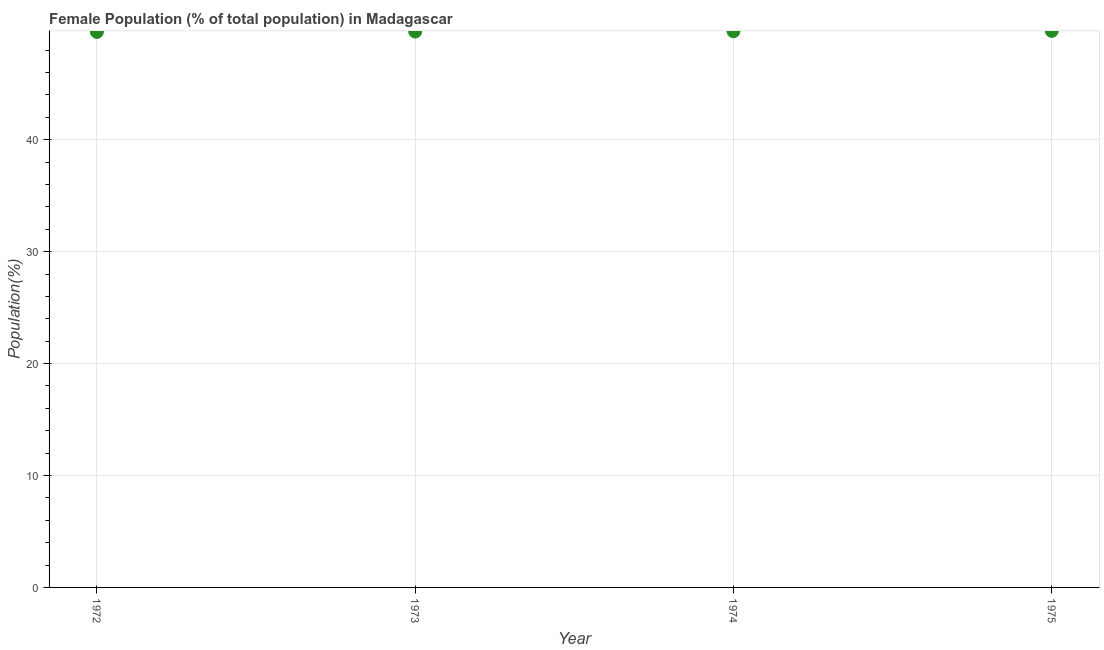What is the female population in 1975?
Keep it short and to the point. 49.72. Across all years, what is the maximum female population?
Offer a very short reply. 49.72. Across all years, what is the minimum female population?
Offer a terse response. 49.63. In which year was the female population maximum?
Keep it short and to the point. 1975. In which year was the female population minimum?
Offer a very short reply. 1972. What is the sum of the female population?
Offer a very short reply. 198.7. What is the difference between the female population in 1973 and 1974?
Offer a very short reply. -0.03. What is the average female population per year?
Your answer should be very brief. 49.67. What is the median female population?
Keep it short and to the point. 49.67. In how many years, is the female population greater than 8 %?
Make the answer very short. 4. What is the ratio of the female population in 1973 to that in 1975?
Give a very brief answer. 1. What is the difference between the highest and the second highest female population?
Keep it short and to the point. 0.03. Is the sum of the female population in 1972 and 1975 greater than the maximum female population across all years?
Make the answer very short. Yes. What is the difference between the highest and the lowest female population?
Ensure brevity in your answer.  0.1. In how many years, is the female population greater than the average female population taken over all years?
Keep it short and to the point. 2. Does the female population monotonically increase over the years?
Provide a short and direct response. Yes. How many dotlines are there?
Offer a terse response. 1. What is the difference between two consecutive major ticks on the Y-axis?
Offer a very short reply. 10. Does the graph contain any zero values?
Offer a terse response. No. Does the graph contain grids?
Offer a very short reply. Yes. What is the title of the graph?
Your response must be concise. Female Population (% of total population) in Madagascar. What is the label or title of the Y-axis?
Offer a very short reply. Population(%). What is the Population(%) in 1972?
Keep it short and to the point. 49.63. What is the Population(%) in 1973?
Ensure brevity in your answer.  49.66. What is the Population(%) in 1974?
Keep it short and to the point. 49.69. What is the Population(%) in 1975?
Your answer should be compact. 49.72. What is the difference between the Population(%) in 1972 and 1973?
Your response must be concise. -0.03. What is the difference between the Population(%) in 1972 and 1974?
Your response must be concise. -0.06. What is the difference between the Population(%) in 1972 and 1975?
Ensure brevity in your answer.  -0.1. What is the difference between the Population(%) in 1973 and 1974?
Your answer should be compact. -0.03. What is the difference between the Population(%) in 1973 and 1975?
Give a very brief answer. -0.06. What is the difference between the Population(%) in 1974 and 1975?
Offer a terse response. -0.03. What is the ratio of the Population(%) in 1972 to that in 1973?
Provide a short and direct response. 1. What is the ratio of the Population(%) in 1972 to that in 1974?
Provide a succinct answer. 1. What is the ratio of the Population(%) in 1972 to that in 1975?
Keep it short and to the point. 1. What is the ratio of the Population(%) in 1973 to that in 1975?
Offer a very short reply. 1. What is the ratio of the Population(%) in 1974 to that in 1975?
Keep it short and to the point. 1. 